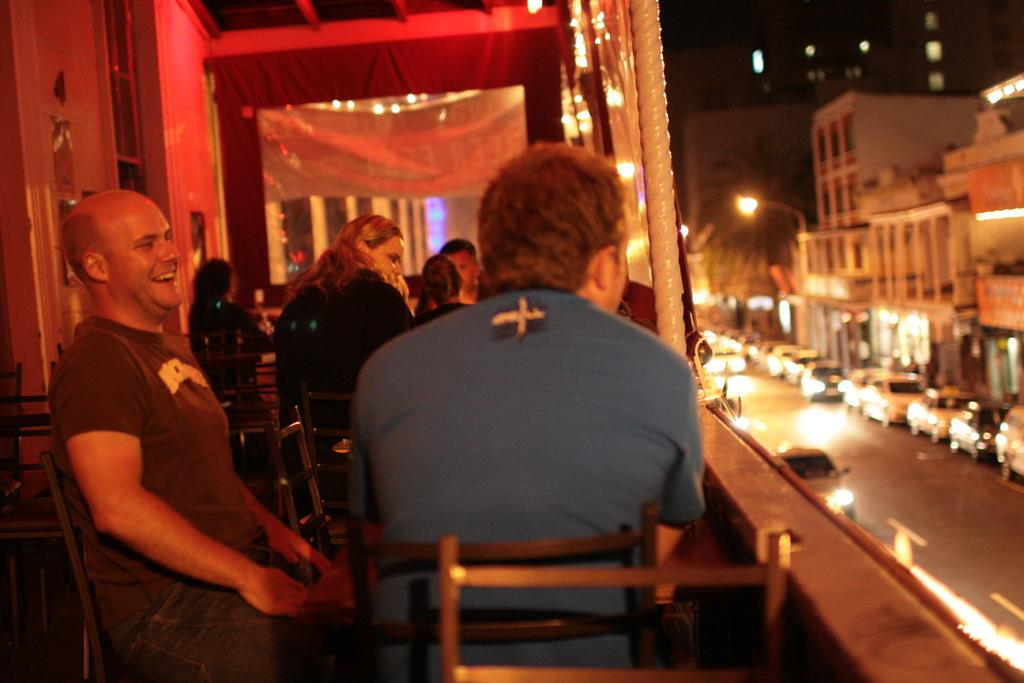What are the people in the image doing? The people in the image are sitting on chairs. What can be seen on the right side of the image? There is a road on the right side of the image. What is happening on the road? There are vehicles on the road. What can be seen in the distance in the image? There are buildings visible in the background of the image. Can you tell me how many memories are present in the image? There are no memories present in the image; it is a photograph that captures a moment in time. 